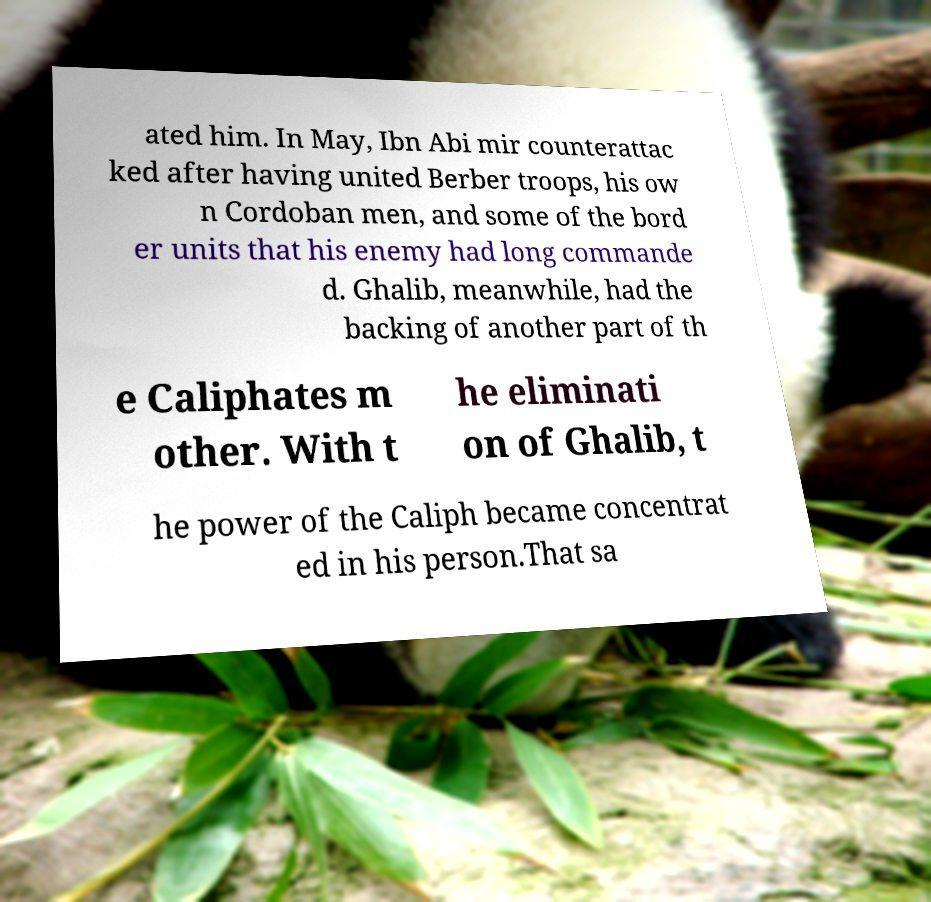Could you assist in decoding the text presented in this image and type it out clearly? ated him. In May, Ibn Abi mir counterattac ked after having united Berber troops, his ow n Cordoban men, and some of the bord er units that his enemy had long commande d. Ghalib, meanwhile, had the backing of another part of th e Caliphates m other. With t he eliminati on of Ghalib, t he power of the Caliph became concentrat ed in his person.That sa 